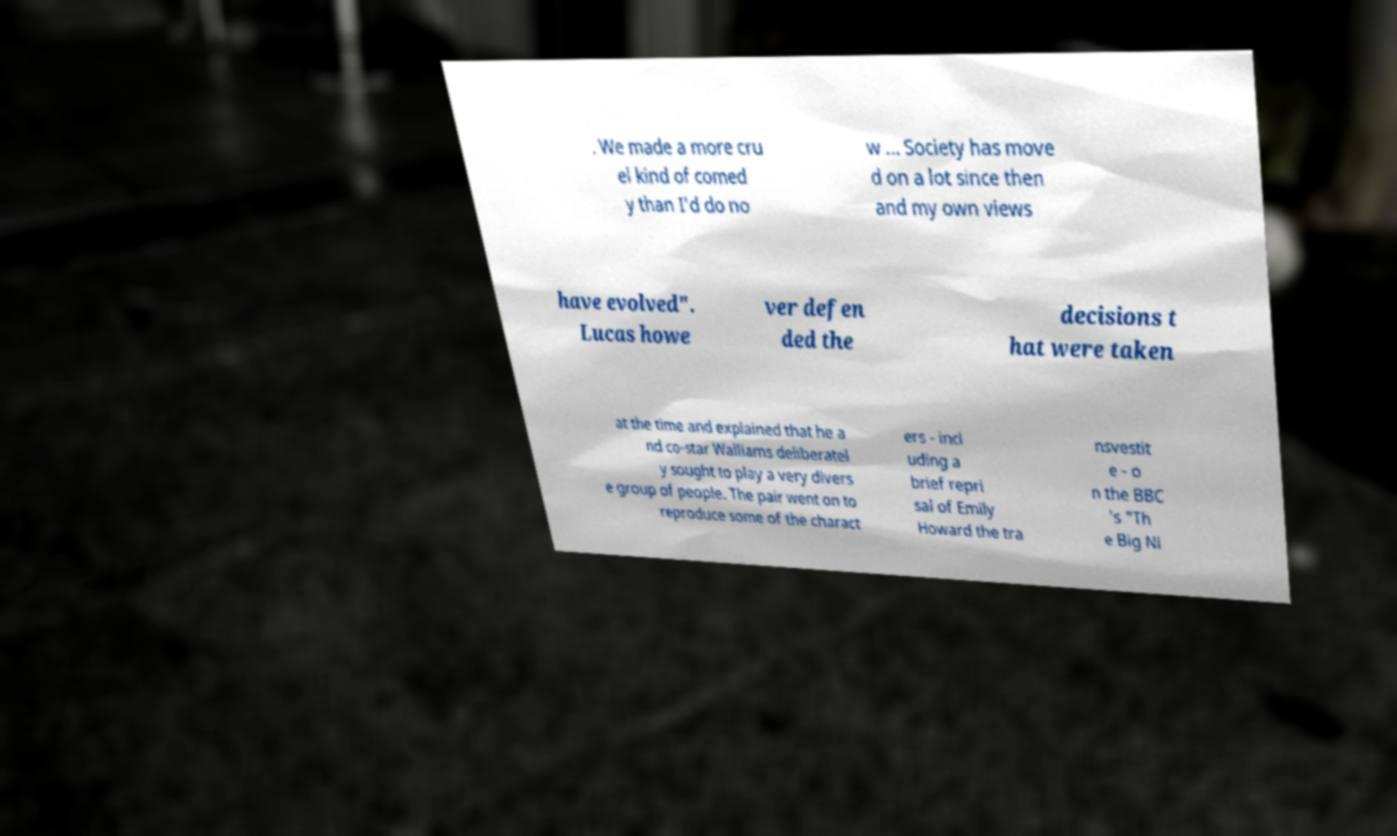For documentation purposes, I need the text within this image transcribed. Could you provide that? . We made a more cru el kind of comed y than I'd do no w ... Society has move d on a lot since then and my own views have evolved". Lucas howe ver defen ded the decisions t hat were taken at the time and explained that he a nd co-star Walliams deliberatel y sought to play a very divers e group of people. The pair went on to reproduce some of the charact ers - incl uding a brief repri sal of Emily Howard the tra nsvestit e - o n the BBC 's "Th e Big Ni 